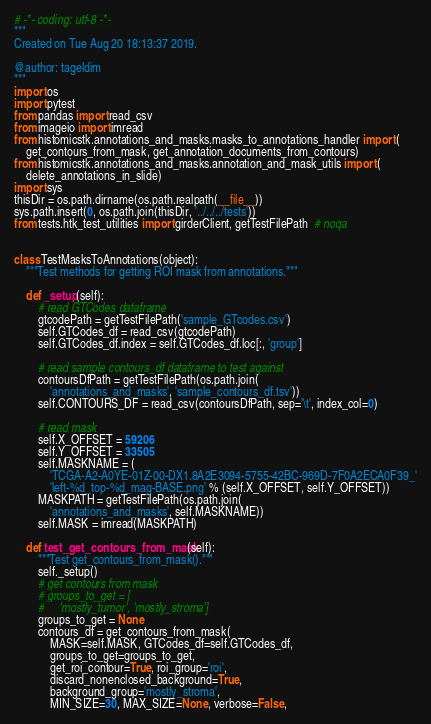Convert code to text. <code><loc_0><loc_0><loc_500><loc_500><_Python_># -*- coding: utf-8 -*-
"""
Created on Tue Aug 20 18:13:37 2019.

@author: tageldim
"""
import os
import pytest
from pandas import read_csv
from imageio import imread
from histomicstk.annotations_and_masks.masks_to_annotations_handler import (
    get_contours_from_mask, get_annotation_documents_from_contours)
from histomicstk.annotations_and_masks.annotation_and_mask_utils import (
    delete_annotations_in_slide)
import sys
thisDir = os.path.dirname(os.path.realpath(__file__))
sys.path.insert(0, os.path.join(thisDir, '../../../tests'))
from tests.htk_test_utilities import girderClient, getTestFilePath  # noqa


class TestMasksToAnnotations(object):
    """Test methods for getting ROI mask from annotations."""

    def _setup(self):
        # read GTCodes dataframe
        gtcodePath = getTestFilePath('sample_GTcodes.csv')
        self.GTCodes_df = read_csv(gtcodePath)
        self.GTCodes_df.index = self.GTCodes_df.loc[:, 'group']

        # read sample contours_df dataframe to test against
        contoursDfPath = getTestFilePath(os.path.join(
            'annotations_and_masks', 'sample_contours_df.tsv'))
        self.CONTOURS_DF = read_csv(contoursDfPath, sep='\t', index_col=0)

        # read mask
        self.X_OFFSET = 59206
        self.Y_OFFSET = 33505
        self.MASKNAME = (
            'TCGA-A2-A0YE-01Z-00-DX1.8A2E3094-5755-42BC-969D-7F0A2ECA0F39_'
            'left-%d_top-%d_mag-BASE.png' % (self.X_OFFSET, self.Y_OFFSET))
        MASKPATH = getTestFilePath(os.path.join(
            'annotations_and_masks', self.MASKNAME))
        self.MASK = imread(MASKPATH)

    def test_get_contours_from_mask(self):
        """Test get_contours_from_mask()."""
        self._setup()
        # get contours from mask
        # groups_to_get = [
        #     'mostly_tumor', 'mostly_stroma']
        groups_to_get = None
        contours_df = get_contours_from_mask(
            MASK=self.MASK, GTCodes_df=self.GTCodes_df,
            groups_to_get=groups_to_get,
            get_roi_contour=True, roi_group='roi',
            discard_nonenclosed_background=True,
            background_group='mostly_stroma',
            MIN_SIZE=30, MAX_SIZE=None, verbose=False,</code> 